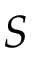Convert formula to latex. <formula><loc_0><loc_0><loc_500><loc_500>S</formula> 